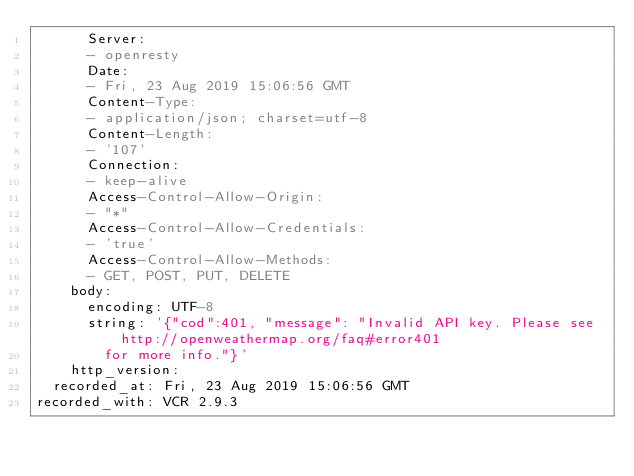Convert code to text. <code><loc_0><loc_0><loc_500><loc_500><_YAML_>      Server:
      - openresty
      Date:
      - Fri, 23 Aug 2019 15:06:56 GMT
      Content-Type:
      - application/json; charset=utf-8
      Content-Length:
      - '107'
      Connection:
      - keep-alive
      Access-Control-Allow-Origin:
      - "*"
      Access-Control-Allow-Credentials:
      - 'true'
      Access-Control-Allow-Methods:
      - GET, POST, PUT, DELETE
    body:
      encoding: UTF-8
      string: '{"cod":401, "message": "Invalid API key. Please see http://openweathermap.org/faq#error401
        for more info."}'
    http_version: 
  recorded_at: Fri, 23 Aug 2019 15:06:56 GMT
recorded_with: VCR 2.9.3
</code> 